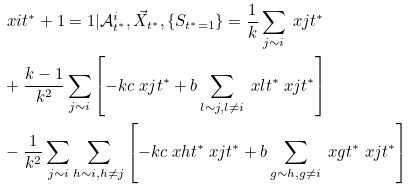<formula> <loc_0><loc_0><loc_500><loc_500>& { \ x { i } { t ^ { * } + 1 } = 1 | \mathcal { A } _ { t ^ { * } } ^ { i } , \vec { X } _ { t ^ { * } } , \{ S _ { t ^ { * } = 1 } \} } = \frac { 1 } { k } \sum _ { j \sim i } \ x { j } { t ^ { * } } \\ & + \frac { k - 1 } { k ^ { 2 } } \sum _ { j \sim i } \left [ - k c \ x { j } { t ^ { * } } + b \sum _ { l \sim j , l \neq i } \ x { l } { t ^ { * } } \ x { j } { t ^ { * } } \right ] \\ & - \frac { 1 } { k ^ { 2 } } \sum _ { j \sim i } \sum _ { h \sim i , h \neq j } \left [ - k c \ x { h } { t ^ { * } } \ x { j } { t ^ { * } } + b \sum _ { g \sim h , g \neq i } \ x { g } { t ^ { * } } \ x { j } { t ^ { * } } \right ]</formula> 